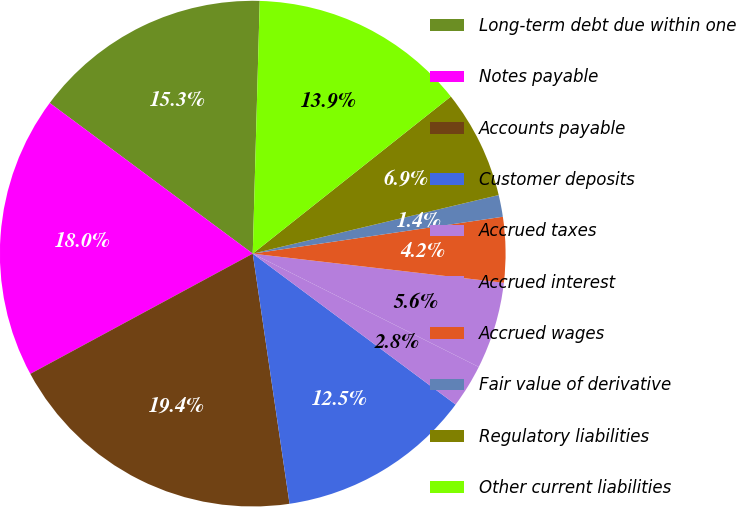<chart> <loc_0><loc_0><loc_500><loc_500><pie_chart><fcel>Long-term debt due within one<fcel>Notes payable<fcel>Accounts payable<fcel>Customer deposits<fcel>Accrued taxes<fcel>Accrued interest<fcel>Accrued wages<fcel>Fair value of derivative<fcel>Regulatory liabilities<fcel>Other current liabilities<nl><fcel>15.28%<fcel>18.05%<fcel>19.44%<fcel>12.5%<fcel>2.78%<fcel>5.56%<fcel>4.17%<fcel>1.39%<fcel>6.95%<fcel>13.89%<nl></chart> 